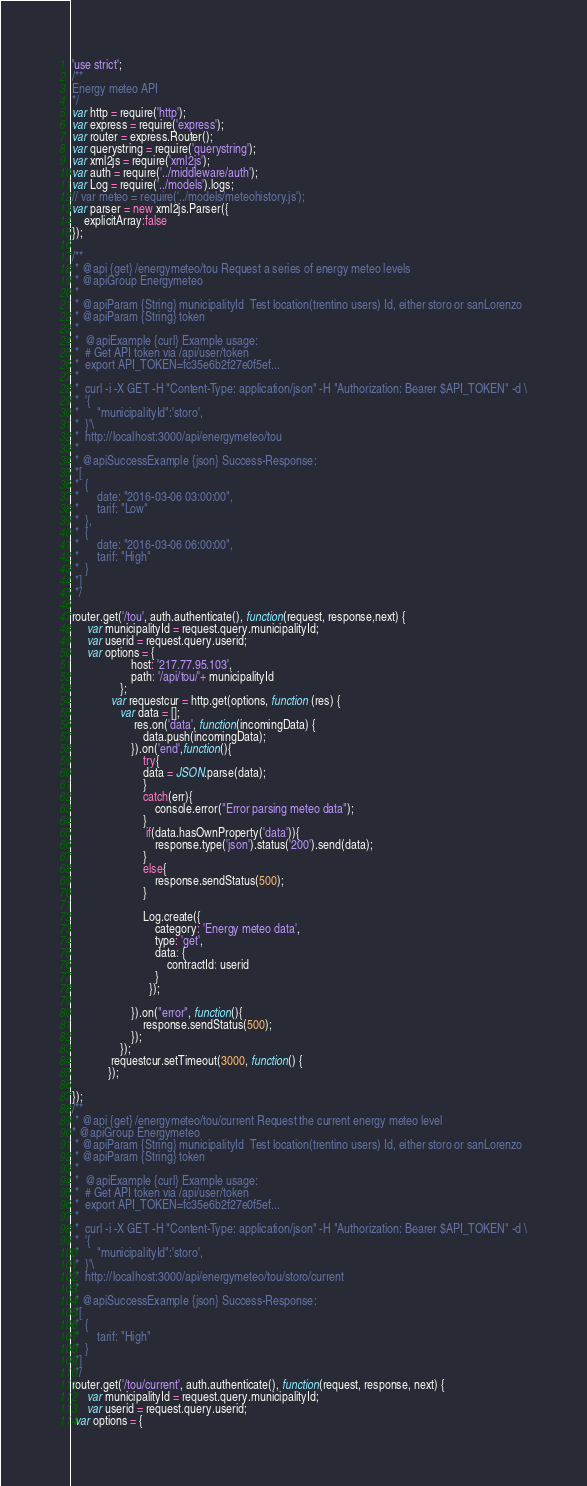Convert code to text. <code><loc_0><loc_0><loc_500><loc_500><_JavaScript_>'use strict';
/**
Energy meteo API
*/
var http = require('http');
var express = require('express');
var router = express.Router();
var querystring = require('querystring');
var xml2js = require('xml2js');
var auth = require('../middleware/auth');
var Log = require('../models').logs;
// var meteo = require('../models/meteohistory.js');
var parser = new xml2js.Parser({
    explicitArray:false
});

/**
 * @api {get} /energymeteo/tou Request a series of energy meteo levels
 * @apiGroup Energymeteo
 *
 * @apiParam {String} municipalityId  Test location(trentino users) Id, either storo or sanLorenzo
 * @apiParam {String} token
 *
 *  @apiExample {curl} Example usage:
 *  # Get API token via /api/user/token
 *  export API_TOKEN=fc35e6b2f27e0f5ef...
 *
 *  curl -i -X GET -H "Content-Type: application/json" -H "Authorization: Bearer $API_TOKEN" -d \
 *  '{
 *      "municipalityId":'storo',
 *  }'\
 *  http://localhost:3000/api/energymeteo/tou 
 *
 * @apiSuccessExample {json} Success-Response:
 *[
 *  {
 *      date: "2016-03-06 03:00:00",
 *      tarif: "Low"
 *  },
 *  {
 *      date: "2016-03-06 06:00:00",
 *      tarif: "High"
 *  }
 *]
 */

router.get('/tou', auth.authenticate(), function(request, response,next) {
	 var municipalityId = request.query.municipalityId;
     var userid = request.query.userid;
     var options = {
                    host: '217.77.95.103',
                    path: '/api/tou/'+ municipalityId
                };
             var requestcur = http.get(options, function (res) {
                var data = [];
                     res.on('data', function(incomingData) {
                        data.push(incomingData);
                    }).on('end',function(){
                        try{
                        data = JSON.parse(data);
                        }
                        catch(err){
                            console.error("Error parsing meteo data");
                        }
                         if(data.hasOwnProperty('data')){
                            response.type('json').status('200').send(data);
                        }
                        else{
                            response.sendStatus(500);
                        }
                        
                        Log.create({
                            category: 'Energy meteo data',
                            type: 'get',
                            data: {
                                contractId: userid
                            }
                          });

                    }).on("error", function(){
                        response.sendStatus(500);
                    });                    
                });
             requestcur.setTimeout(3000, function() {
            });
            
});
/**
 * @api {get} /energymeteo/tou/current Request the current energy meteo level
* @apiGroup Energymeteo
 * @apiParam {String} municipalityId  Test location(trentino users) Id, either storo or sanLorenzo
 * @apiParam {String} token
 *
 *  @apiExample {curl} Example usage:
 *  # Get API token via /api/user/token
 *  export API_TOKEN=fc35e6b2f27e0f5ef...
 *
 *  curl -i -X GET -H "Content-Type: application/json" -H "Authorization: Bearer $API_TOKEN" -d \
 *  '{
 *      "municipalityId":'storo',
 *  }'\
 *  http://localhost:3000/api/energymeteo/tou/storo/current
 *
 * @apiSuccessExample {json} Success-Response:
 *[
 *  {
 *      tarif: "High"
 *  }
 *]
 */
router.get('/tou/current', auth.authenticate(), function(request, response, next) {
	 var municipalityId = request.query.municipalityId;
     var userid = request.query.userid;
 var options = {</code> 